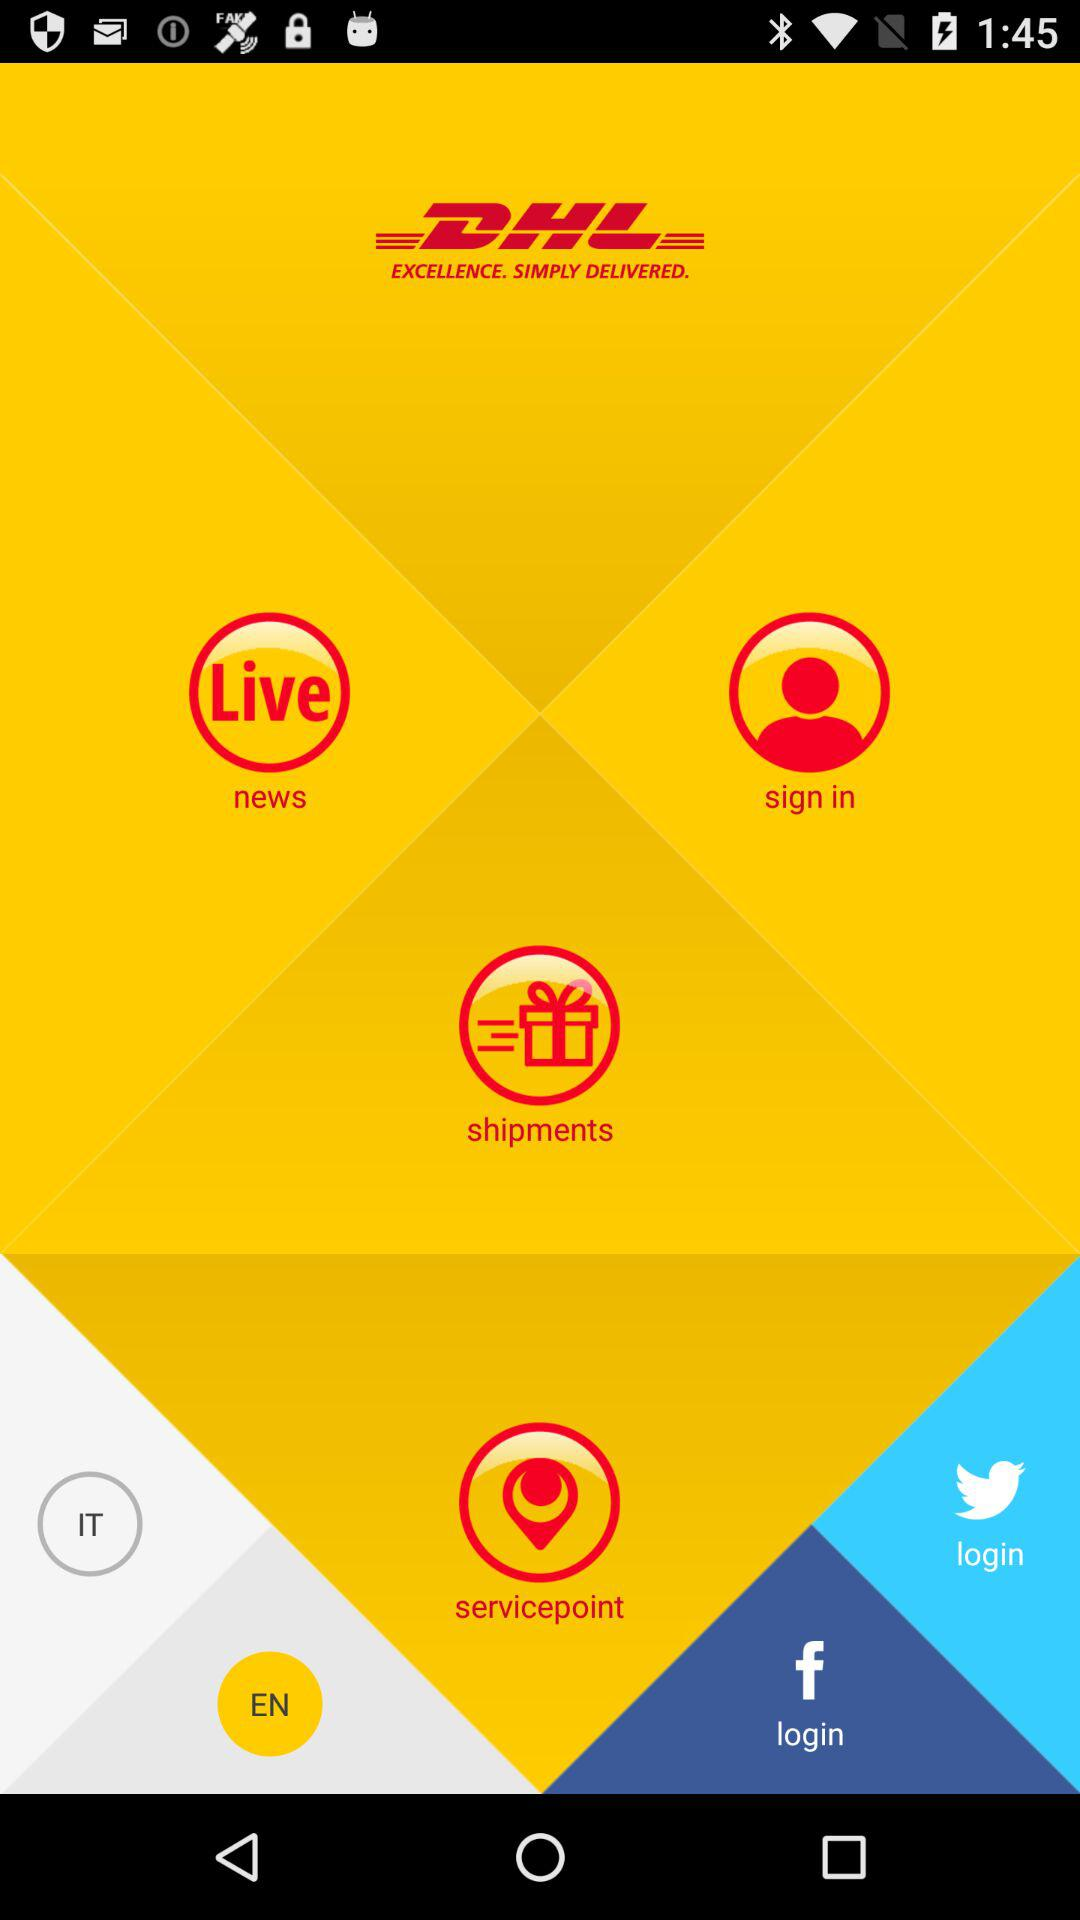What is the name of the application? The name of the application is "DHL". 